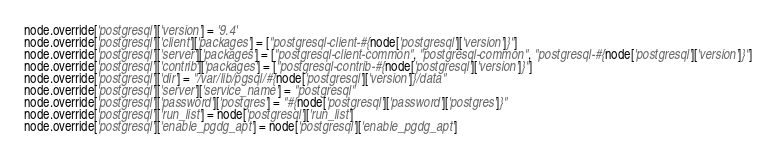<code> <loc_0><loc_0><loc_500><loc_500><_Ruby_>node.override['postgresql']['version'] = '9.4'
node.override['postgresql']['client']['packages'] = ["postgresql-client-#{node['postgresql']['version']}"]
node.override['postgresql']['server']['packages'] = ["postgresql-client-common", "postgresql-common", "postgresql-#{node['postgresql']['version']}"]
node.override['postgresql']['contrib']['packages'] = ["postgresql-contrib-#{node['postgresql']['version']}"]
node.override['postgresql']['dir'] = "/var/lib/pgsql/#{node['postgresql']['version']}/data"
node.override['postgresql']['server']['service_name'] = "postgresql"
node.override['postgresql']['password']['postgres'] = "#{node['postgresql']['password']['postgres']}"
node.override['postgresql']['run_list'] = node['postgresql']['run_list']
node.override['postgresql']['enable_pgdg_apt'] = node['postgresql']['enable_pgdg_apt']
</code> 